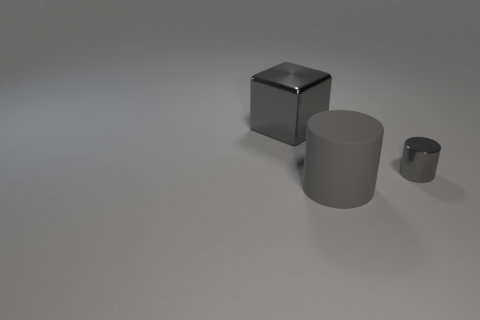Add 2 gray blocks. How many objects exist? 5 Subtract all blocks. How many objects are left? 2 Subtract all blue cylinders. Subtract all green cubes. How many cylinders are left? 2 Subtract all tiny gray things. Subtract all large green rubber spheres. How many objects are left? 2 Add 3 gray metallic blocks. How many gray metallic blocks are left? 4 Add 3 objects. How many objects exist? 6 Subtract 0 red cylinders. How many objects are left? 3 